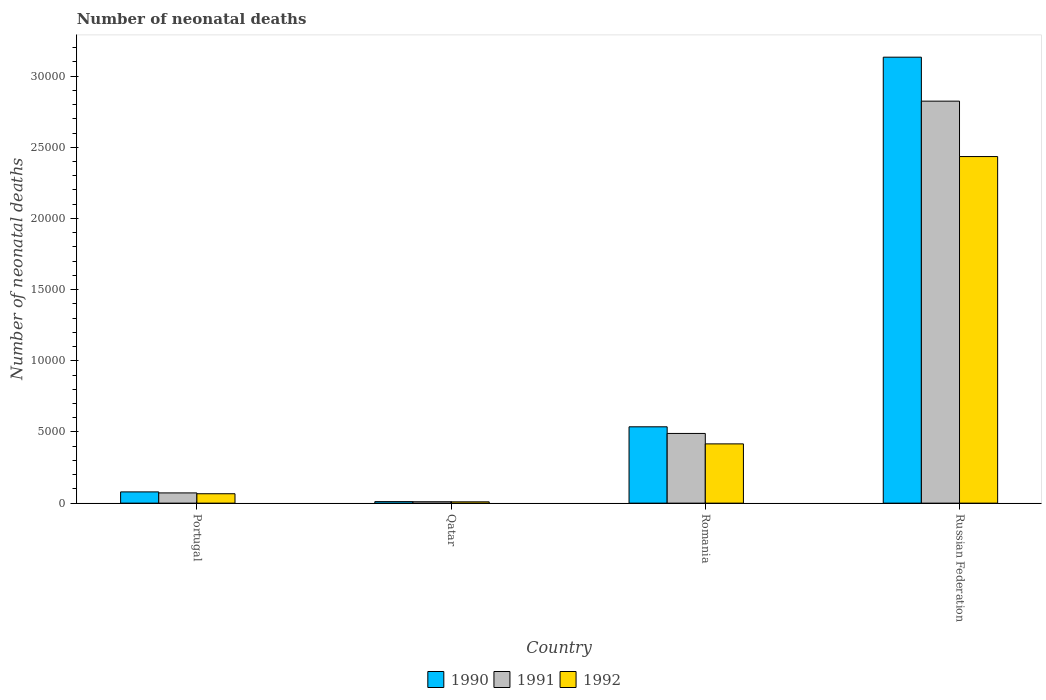How many different coloured bars are there?
Ensure brevity in your answer.  3. How many groups of bars are there?
Your answer should be very brief. 4. Are the number of bars per tick equal to the number of legend labels?
Give a very brief answer. Yes. How many bars are there on the 1st tick from the right?
Provide a succinct answer. 3. What is the number of neonatal deaths in in 1990 in Russian Federation?
Ensure brevity in your answer.  3.13e+04. Across all countries, what is the maximum number of neonatal deaths in in 1991?
Give a very brief answer. 2.82e+04. Across all countries, what is the minimum number of neonatal deaths in in 1991?
Provide a short and direct response. 99. In which country was the number of neonatal deaths in in 1991 maximum?
Your answer should be compact. Russian Federation. In which country was the number of neonatal deaths in in 1991 minimum?
Provide a succinct answer. Qatar. What is the total number of neonatal deaths in in 1990 in the graph?
Provide a succinct answer. 3.76e+04. What is the difference between the number of neonatal deaths in in 1992 in Qatar and that in Romania?
Your answer should be very brief. -4071. What is the difference between the number of neonatal deaths in in 1991 in Qatar and the number of neonatal deaths in in 1992 in Portugal?
Make the answer very short. -561. What is the average number of neonatal deaths in in 1992 per country?
Ensure brevity in your answer.  7315.25. What is the difference between the number of neonatal deaths in of/in 1990 and number of neonatal deaths in of/in 1991 in Qatar?
Provide a succinct answer. 8. What is the ratio of the number of neonatal deaths in in 1990 in Portugal to that in Qatar?
Give a very brief answer. 7.38. Is the number of neonatal deaths in in 1992 in Portugal less than that in Qatar?
Your answer should be compact. No. What is the difference between the highest and the second highest number of neonatal deaths in in 1990?
Make the answer very short. 4572. What is the difference between the highest and the lowest number of neonatal deaths in in 1990?
Ensure brevity in your answer.  3.12e+04. What does the 2nd bar from the right in Qatar represents?
Your response must be concise. 1991. Is it the case that in every country, the sum of the number of neonatal deaths in in 1992 and number of neonatal deaths in in 1991 is greater than the number of neonatal deaths in in 1990?
Make the answer very short. Yes. Are all the bars in the graph horizontal?
Make the answer very short. No. Are the values on the major ticks of Y-axis written in scientific E-notation?
Your answer should be very brief. No. Does the graph contain grids?
Offer a terse response. No. Where does the legend appear in the graph?
Your response must be concise. Bottom center. What is the title of the graph?
Keep it short and to the point. Number of neonatal deaths. Does "1982" appear as one of the legend labels in the graph?
Your answer should be very brief. No. What is the label or title of the X-axis?
Offer a very short reply. Country. What is the label or title of the Y-axis?
Give a very brief answer. Number of neonatal deaths. What is the Number of neonatal deaths in 1990 in Portugal?
Your response must be concise. 790. What is the Number of neonatal deaths in 1991 in Portugal?
Your response must be concise. 719. What is the Number of neonatal deaths in 1992 in Portugal?
Your answer should be compact. 660. What is the Number of neonatal deaths in 1990 in Qatar?
Make the answer very short. 107. What is the Number of neonatal deaths of 1992 in Qatar?
Your answer should be very brief. 92. What is the Number of neonatal deaths of 1990 in Romania?
Provide a succinct answer. 5362. What is the Number of neonatal deaths in 1991 in Romania?
Give a very brief answer. 4896. What is the Number of neonatal deaths in 1992 in Romania?
Your response must be concise. 4163. What is the Number of neonatal deaths in 1990 in Russian Federation?
Offer a terse response. 3.13e+04. What is the Number of neonatal deaths in 1991 in Russian Federation?
Make the answer very short. 2.82e+04. What is the Number of neonatal deaths in 1992 in Russian Federation?
Offer a terse response. 2.43e+04. Across all countries, what is the maximum Number of neonatal deaths of 1990?
Offer a terse response. 3.13e+04. Across all countries, what is the maximum Number of neonatal deaths in 1991?
Offer a terse response. 2.82e+04. Across all countries, what is the maximum Number of neonatal deaths of 1992?
Offer a terse response. 2.43e+04. Across all countries, what is the minimum Number of neonatal deaths of 1990?
Your answer should be compact. 107. Across all countries, what is the minimum Number of neonatal deaths of 1992?
Provide a succinct answer. 92. What is the total Number of neonatal deaths in 1990 in the graph?
Your response must be concise. 3.76e+04. What is the total Number of neonatal deaths in 1991 in the graph?
Your answer should be very brief. 3.40e+04. What is the total Number of neonatal deaths of 1992 in the graph?
Give a very brief answer. 2.93e+04. What is the difference between the Number of neonatal deaths in 1990 in Portugal and that in Qatar?
Provide a short and direct response. 683. What is the difference between the Number of neonatal deaths of 1991 in Portugal and that in Qatar?
Your response must be concise. 620. What is the difference between the Number of neonatal deaths in 1992 in Portugal and that in Qatar?
Your answer should be very brief. 568. What is the difference between the Number of neonatal deaths of 1990 in Portugal and that in Romania?
Make the answer very short. -4572. What is the difference between the Number of neonatal deaths of 1991 in Portugal and that in Romania?
Provide a short and direct response. -4177. What is the difference between the Number of neonatal deaths of 1992 in Portugal and that in Romania?
Offer a very short reply. -3503. What is the difference between the Number of neonatal deaths in 1990 in Portugal and that in Russian Federation?
Provide a succinct answer. -3.05e+04. What is the difference between the Number of neonatal deaths in 1991 in Portugal and that in Russian Federation?
Provide a succinct answer. -2.75e+04. What is the difference between the Number of neonatal deaths in 1992 in Portugal and that in Russian Federation?
Your response must be concise. -2.37e+04. What is the difference between the Number of neonatal deaths in 1990 in Qatar and that in Romania?
Give a very brief answer. -5255. What is the difference between the Number of neonatal deaths in 1991 in Qatar and that in Romania?
Give a very brief answer. -4797. What is the difference between the Number of neonatal deaths of 1992 in Qatar and that in Romania?
Offer a very short reply. -4071. What is the difference between the Number of neonatal deaths in 1990 in Qatar and that in Russian Federation?
Offer a very short reply. -3.12e+04. What is the difference between the Number of neonatal deaths in 1991 in Qatar and that in Russian Federation?
Make the answer very short. -2.81e+04. What is the difference between the Number of neonatal deaths in 1992 in Qatar and that in Russian Federation?
Your answer should be compact. -2.43e+04. What is the difference between the Number of neonatal deaths of 1990 in Romania and that in Russian Federation?
Keep it short and to the point. -2.60e+04. What is the difference between the Number of neonatal deaths of 1991 in Romania and that in Russian Federation?
Your answer should be very brief. -2.33e+04. What is the difference between the Number of neonatal deaths of 1992 in Romania and that in Russian Federation?
Offer a very short reply. -2.02e+04. What is the difference between the Number of neonatal deaths of 1990 in Portugal and the Number of neonatal deaths of 1991 in Qatar?
Provide a short and direct response. 691. What is the difference between the Number of neonatal deaths of 1990 in Portugal and the Number of neonatal deaths of 1992 in Qatar?
Your answer should be compact. 698. What is the difference between the Number of neonatal deaths in 1991 in Portugal and the Number of neonatal deaths in 1992 in Qatar?
Provide a succinct answer. 627. What is the difference between the Number of neonatal deaths in 1990 in Portugal and the Number of neonatal deaths in 1991 in Romania?
Provide a short and direct response. -4106. What is the difference between the Number of neonatal deaths in 1990 in Portugal and the Number of neonatal deaths in 1992 in Romania?
Give a very brief answer. -3373. What is the difference between the Number of neonatal deaths in 1991 in Portugal and the Number of neonatal deaths in 1992 in Romania?
Your response must be concise. -3444. What is the difference between the Number of neonatal deaths in 1990 in Portugal and the Number of neonatal deaths in 1991 in Russian Federation?
Provide a short and direct response. -2.74e+04. What is the difference between the Number of neonatal deaths in 1990 in Portugal and the Number of neonatal deaths in 1992 in Russian Federation?
Make the answer very short. -2.36e+04. What is the difference between the Number of neonatal deaths of 1991 in Portugal and the Number of neonatal deaths of 1992 in Russian Federation?
Give a very brief answer. -2.36e+04. What is the difference between the Number of neonatal deaths of 1990 in Qatar and the Number of neonatal deaths of 1991 in Romania?
Your answer should be compact. -4789. What is the difference between the Number of neonatal deaths of 1990 in Qatar and the Number of neonatal deaths of 1992 in Romania?
Keep it short and to the point. -4056. What is the difference between the Number of neonatal deaths of 1991 in Qatar and the Number of neonatal deaths of 1992 in Romania?
Offer a terse response. -4064. What is the difference between the Number of neonatal deaths of 1990 in Qatar and the Number of neonatal deaths of 1991 in Russian Federation?
Keep it short and to the point. -2.81e+04. What is the difference between the Number of neonatal deaths of 1990 in Qatar and the Number of neonatal deaths of 1992 in Russian Federation?
Give a very brief answer. -2.42e+04. What is the difference between the Number of neonatal deaths of 1991 in Qatar and the Number of neonatal deaths of 1992 in Russian Federation?
Offer a terse response. -2.42e+04. What is the difference between the Number of neonatal deaths of 1990 in Romania and the Number of neonatal deaths of 1991 in Russian Federation?
Offer a very short reply. -2.29e+04. What is the difference between the Number of neonatal deaths of 1990 in Romania and the Number of neonatal deaths of 1992 in Russian Federation?
Ensure brevity in your answer.  -1.90e+04. What is the difference between the Number of neonatal deaths of 1991 in Romania and the Number of neonatal deaths of 1992 in Russian Federation?
Your answer should be compact. -1.94e+04. What is the average Number of neonatal deaths in 1990 per country?
Offer a terse response. 9396.5. What is the average Number of neonatal deaths of 1991 per country?
Offer a very short reply. 8488. What is the average Number of neonatal deaths of 1992 per country?
Give a very brief answer. 7315.25. What is the difference between the Number of neonatal deaths of 1990 and Number of neonatal deaths of 1991 in Portugal?
Your response must be concise. 71. What is the difference between the Number of neonatal deaths in 1990 and Number of neonatal deaths in 1992 in Portugal?
Your answer should be very brief. 130. What is the difference between the Number of neonatal deaths of 1991 and Number of neonatal deaths of 1992 in Portugal?
Make the answer very short. 59. What is the difference between the Number of neonatal deaths of 1990 and Number of neonatal deaths of 1991 in Qatar?
Make the answer very short. 8. What is the difference between the Number of neonatal deaths of 1991 and Number of neonatal deaths of 1992 in Qatar?
Keep it short and to the point. 7. What is the difference between the Number of neonatal deaths of 1990 and Number of neonatal deaths of 1991 in Romania?
Provide a short and direct response. 466. What is the difference between the Number of neonatal deaths of 1990 and Number of neonatal deaths of 1992 in Romania?
Your answer should be compact. 1199. What is the difference between the Number of neonatal deaths in 1991 and Number of neonatal deaths in 1992 in Romania?
Make the answer very short. 733. What is the difference between the Number of neonatal deaths in 1990 and Number of neonatal deaths in 1991 in Russian Federation?
Your answer should be very brief. 3089. What is the difference between the Number of neonatal deaths in 1990 and Number of neonatal deaths in 1992 in Russian Federation?
Your response must be concise. 6981. What is the difference between the Number of neonatal deaths of 1991 and Number of neonatal deaths of 1992 in Russian Federation?
Give a very brief answer. 3892. What is the ratio of the Number of neonatal deaths of 1990 in Portugal to that in Qatar?
Your answer should be compact. 7.38. What is the ratio of the Number of neonatal deaths of 1991 in Portugal to that in Qatar?
Your answer should be very brief. 7.26. What is the ratio of the Number of neonatal deaths of 1992 in Portugal to that in Qatar?
Offer a terse response. 7.17. What is the ratio of the Number of neonatal deaths in 1990 in Portugal to that in Romania?
Provide a short and direct response. 0.15. What is the ratio of the Number of neonatal deaths of 1991 in Portugal to that in Romania?
Your answer should be very brief. 0.15. What is the ratio of the Number of neonatal deaths in 1992 in Portugal to that in Romania?
Offer a very short reply. 0.16. What is the ratio of the Number of neonatal deaths of 1990 in Portugal to that in Russian Federation?
Provide a succinct answer. 0.03. What is the ratio of the Number of neonatal deaths of 1991 in Portugal to that in Russian Federation?
Offer a very short reply. 0.03. What is the ratio of the Number of neonatal deaths of 1992 in Portugal to that in Russian Federation?
Your answer should be compact. 0.03. What is the ratio of the Number of neonatal deaths of 1990 in Qatar to that in Romania?
Your answer should be compact. 0.02. What is the ratio of the Number of neonatal deaths of 1991 in Qatar to that in Romania?
Offer a terse response. 0.02. What is the ratio of the Number of neonatal deaths in 1992 in Qatar to that in Romania?
Your response must be concise. 0.02. What is the ratio of the Number of neonatal deaths in 1990 in Qatar to that in Russian Federation?
Keep it short and to the point. 0. What is the ratio of the Number of neonatal deaths in 1991 in Qatar to that in Russian Federation?
Provide a succinct answer. 0. What is the ratio of the Number of neonatal deaths in 1992 in Qatar to that in Russian Federation?
Your response must be concise. 0. What is the ratio of the Number of neonatal deaths in 1990 in Romania to that in Russian Federation?
Your answer should be compact. 0.17. What is the ratio of the Number of neonatal deaths in 1991 in Romania to that in Russian Federation?
Your answer should be compact. 0.17. What is the ratio of the Number of neonatal deaths in 1992 in Romania to that in Russian Federation?
Your answer should be very brief. 0.17. What is the difference between the highest and the second highest Number of neonatal deaths in 1990?
Your answer should be very brief. 2.60e+04. What is the difference between the highest and the second highest Number of neonatal deaths of 1991?
Provide a short and direct response. 2.33e+04. What is the difference between the highest and the second highest Number of neonatal deaths in 1992?
Make the answer very short. 2.02e+04. What is the difference between the highest and the lowest Number of neonatal deaths of 1990?
Provide a short and direct response. 3.12e+04. What is the difference between the highest and the lowest Number of neonatal deaths of 1991?
Provide a succinct answer. 2.81e+04. What is the difference between the highest and the lowest Number of neonatal deaths of 1992?
Your answer should be very brief. 2.43e+04. 